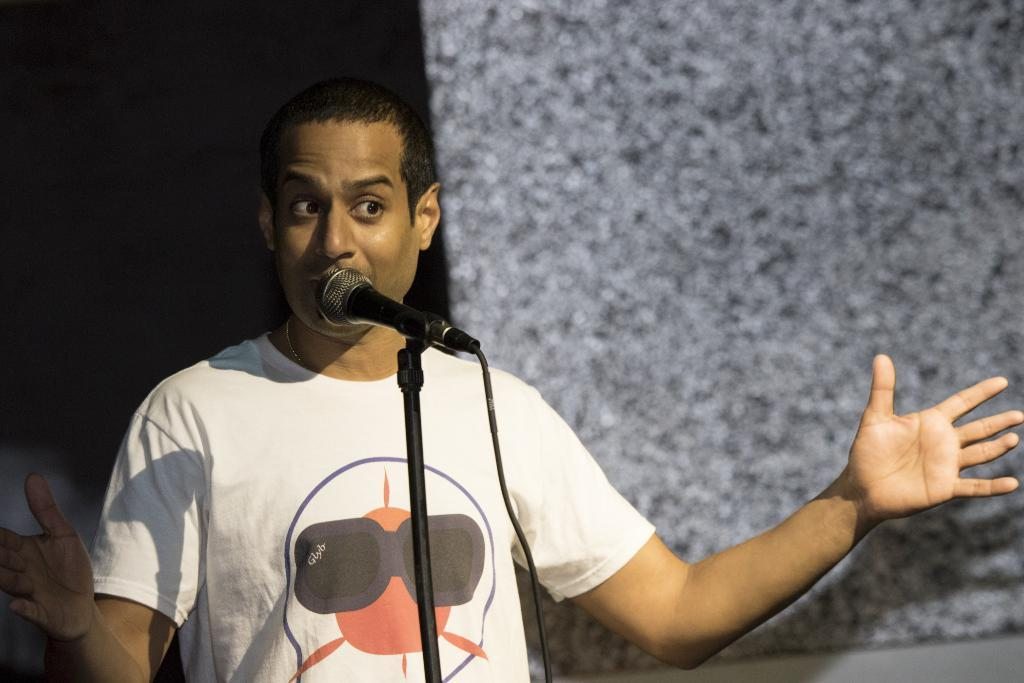What is the main subject of the image? There is a person in the image. What is the person doing in the image? The person is standing in front of a microphone. How is the microphone positioned in the image? The microphone is placed on a stand. Can you see any ducks or a garden in the image? No, there are no ducks or garden present in the image. What type of calculator is the person using in the image? There is no calculator visible in the image. 